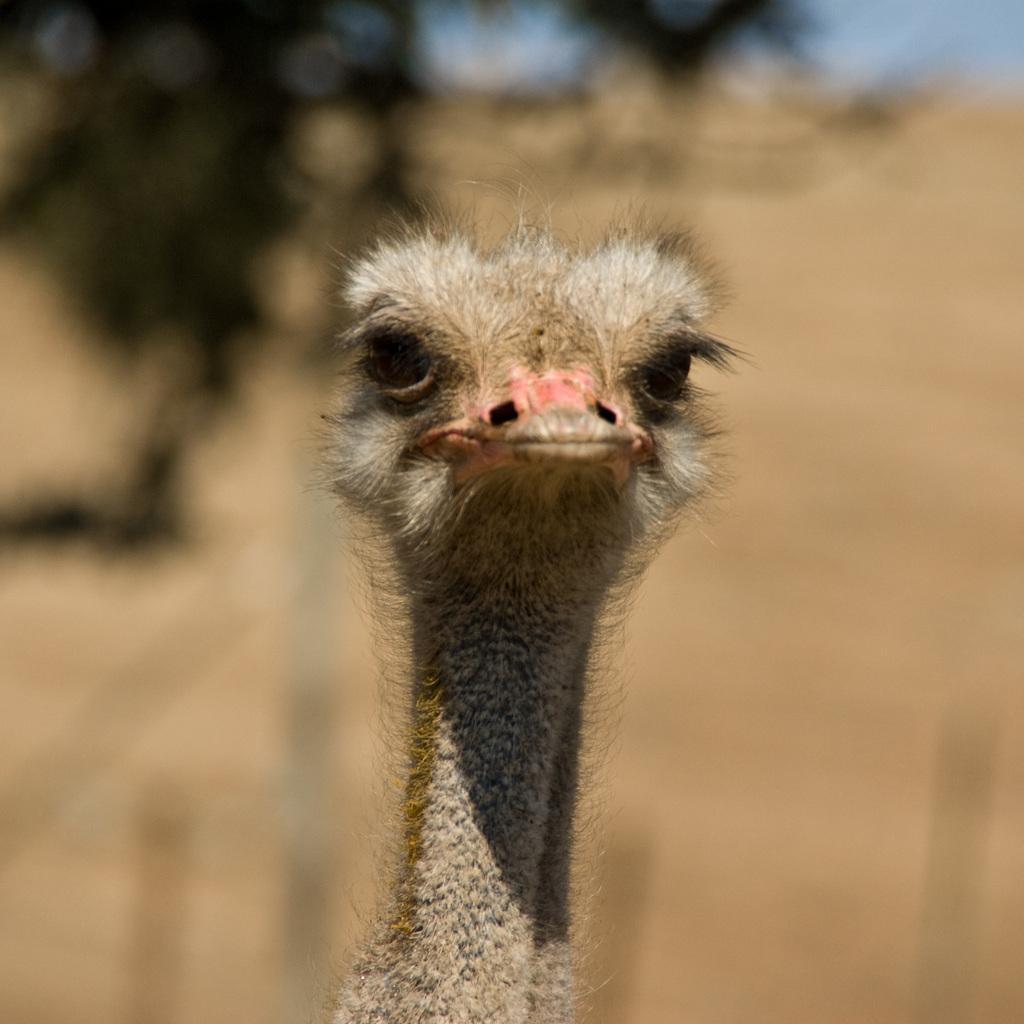Could you give a brief overview of what you see in this image? In this image in the foreground there is one animal, and in the background there are trees and sand. 